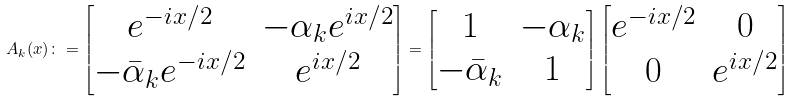Convert formula to latex. <formula><loc_0><loc_0><loc_500><loc_500>A _ { k } ( x ) \colon = \begin{bmatrix} e ^ { - i x / 2 } & - \alpha _ { k } e ^ { i x / 2 } \\ - \bar { \alpha } _ { k } e ^ { - i x / 2 } & e ^ { i x / 2 } \end{bmatrix} = \begin{bmatrix} 1 & - \alpha _ { k } \\ - \bar { \alpha } _ { k } & 1 \end{bmatrix} \begin{bmatrix} e ^ { - i x / 2 } & 0 \\ 0 & e ^ { i x / 2 } \end{bmatrix}</formula> 